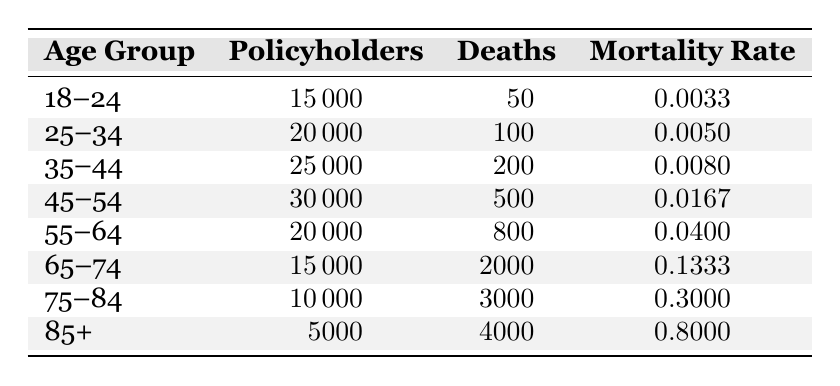What is the mortality rate for the age group 45-54? The table shows that for the age group 45-54, the mortality rate is listed as 0.0167.
Answer: 0.0167 How many deaths occurred in the age group 65-74? Referring to the table, the number of deaths in the age group 65-74 is 2000.
Answer: 2000 Which age group has the highest number of policyholders? By inspecting the table, the age group 45-54 has the highest number of policyholders at 30,000.
Answer: 45-54 What is the total number of deaths across all age groups? Adding up the deaths from each age group: 50 + 100 + 200 + 500 + 800 + 2000 + 3000 + 4000 = 65,650.
Answer: 6650 Is the mortality rate for age group 85+ greater than 0.7? Looking at the table, the mortality rate for age group 85+ is 0.8000, which is greater than 0.7.
Answer: Yes What is the average mortality rate across all age groups? To find the average, add the mortality rates: 0.0033 + 0.005 + 0.008 + 0.0167 + 0.04 + 0.1333 + 0.3 + 0.8 = 1.3063, then divide by the number of age groups (8): 1.3063 / 8 = 0.1632875, which rounds to approximately 0.1633.
Answer: 0.1633 How many policyholders are there in the age group with the second highest mortality rate? The second highest mortality rate is for the age group 75-84, which has 10,000 policyholders according to the table.
Answer: 10,000 Which age group has the least mortality rate? By assessing the mortalities, it's clear that the age group 18-24 has the least mortality rate of 0.0033.
Answer: 18-24 